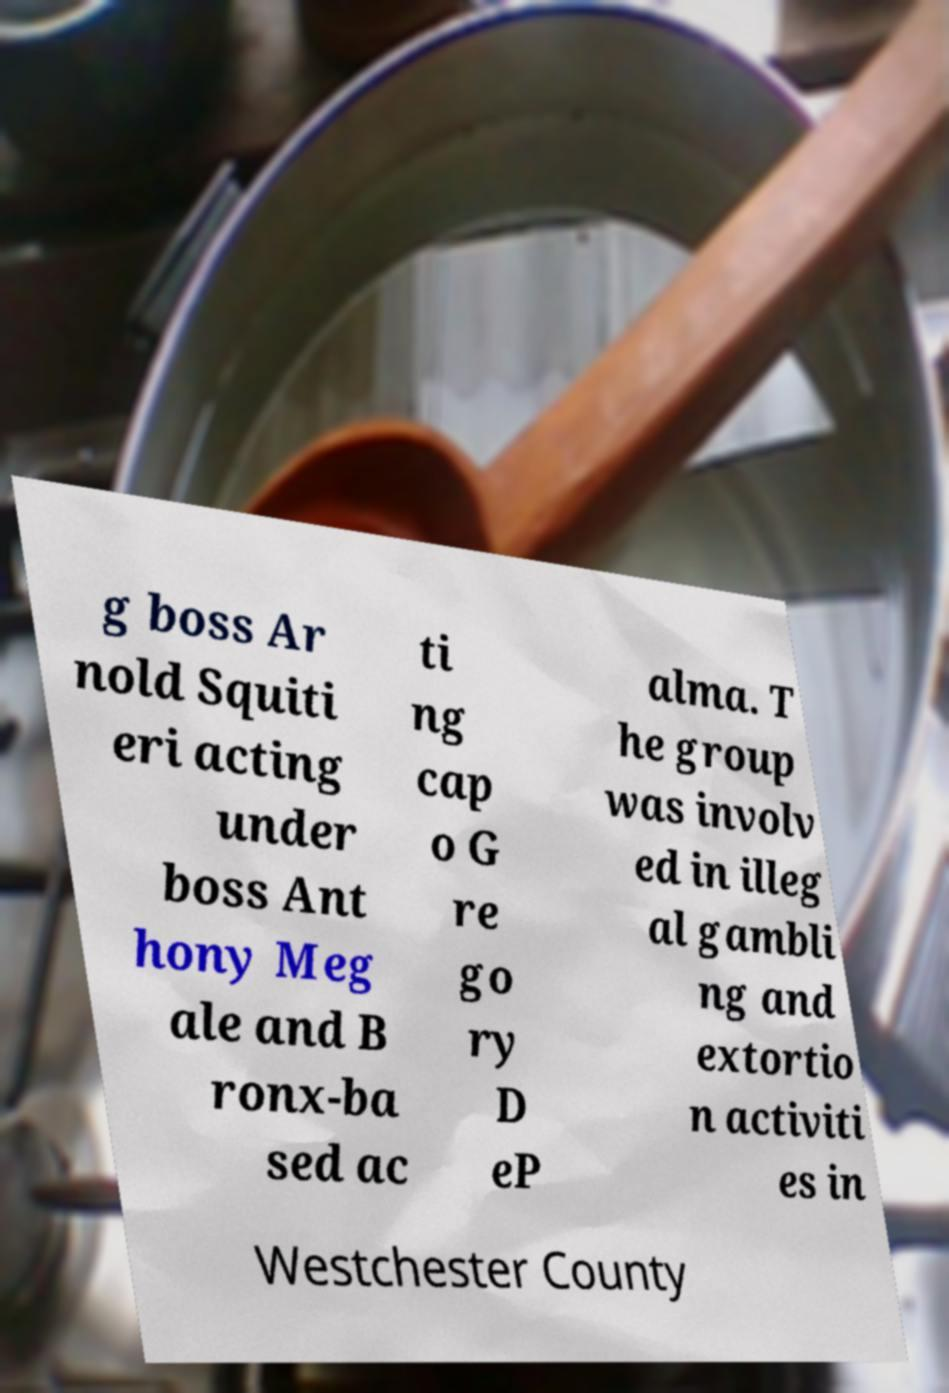Can you read and provide the text displayed in the image?This photo seems to have some interesting text. Can you extract and type it out for me? g boss Ar nold Squiti eri acting under boss Ant hony Meg ale and B ronx-ba sed ac ti ng cap o G re go ry D eP alma. T he group was involv ed in illeg al gambli ng and extortio n activiti es in Westchester County 